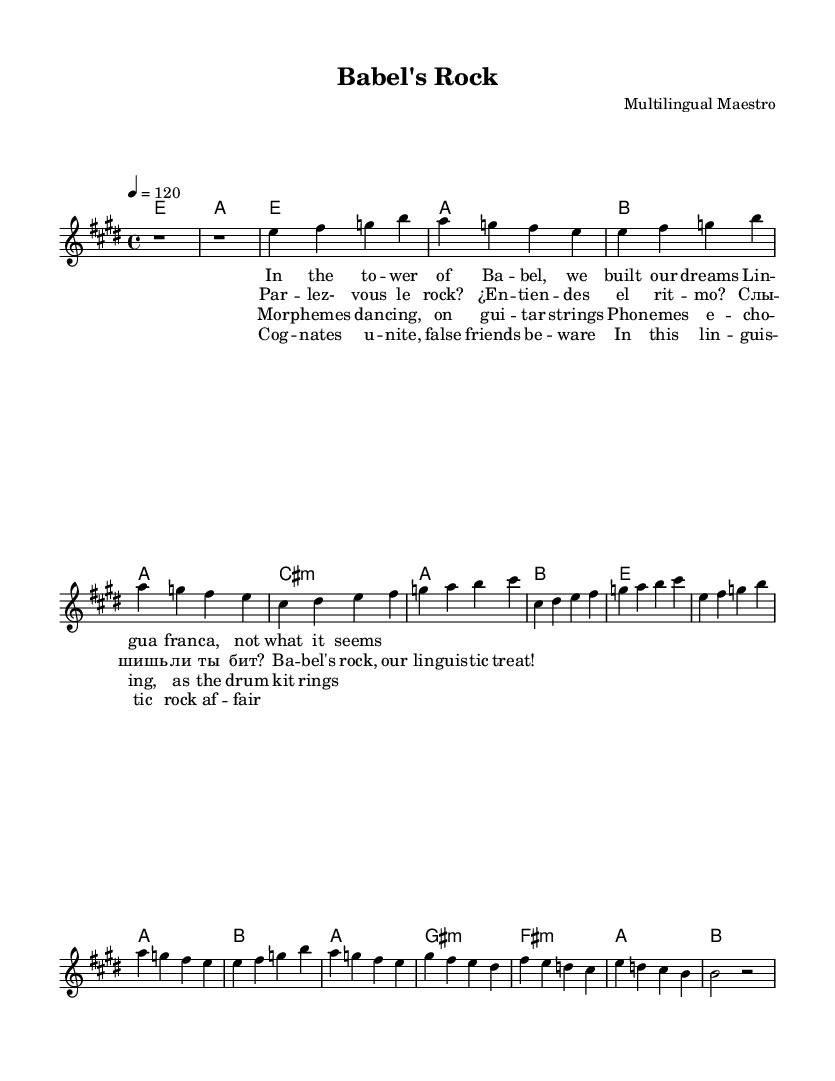What is the key signature of this music? The key signature is E major, which has four sharps: F#, C#, G#, and D#. This can be identified at the beginning of the sheet music where the key signature is indicated.
Answer: E major What is the time signature of the piece? The time signature is 4/4, which is noted at the beginning of the score. This indicates that there are four beats in each measure and the quarter note receives one beat.
Answer: 4/4 What is the tempo marking for this piece? The tempo marking is 120 beats per minute, indicated in the score with the note symbol "4 = 120" which means that a quarter note equals 120 beats per minute.
Answer: 120 beats per minute In which section do we find the multilingual chorus? The multilingual chorus is found in the chorus section of the sheet music, where lyrics include phrases in French, Spanish, and Russian. This is designed to create a lively and inclusive multilingual experience.
Answer: Chorus How many verses are there in the score? There are two verses in the score, as labeled in the structure with "Verse 1" and "Verse 2." Both sections introduce different lyrical themes and musical lines in the piece.
Answer: Two What unique musical element is featured in the bridge? The unique musical element in the bridge is the use of wordplay and the interaction of different linguistic elements. The bridge combines themes of cognition and language, paralleling the music structure with its lyrical content.
Answer: Wordplay How does the tempo affect the feel of this rock piece? The tempo of 120 beats per minute gives the piece an upbeat, energetic feel typical of rock music. This brisk speed allows for a driving rhythm that encourages engagement from listeners and performers alike.
Answer: Energetic 